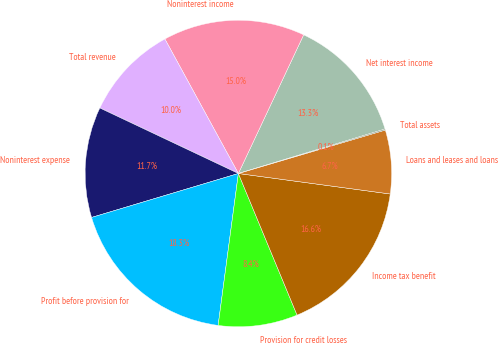<chart> <loc_0><loc_0><loc_500><loc_500><pie_chart><fcel>Net interest income<fcel>Noninterest income<fcel>Total revenue<fcel>Noninterest expense<fcel>Profit before provision for<fcel>Provision for credit losses<fcel>Income tax benefit<fcel>Loans and leases and loans<fcel>Total assets<nl><fcel>13.31%<fcel>14.96%<fcel>10.01%<fcel>11.66%<fcel>18.26%<fcel>8.36%<fcel>16.61%<fcel>6.71%<fcel>0.11%<nl></chart> 